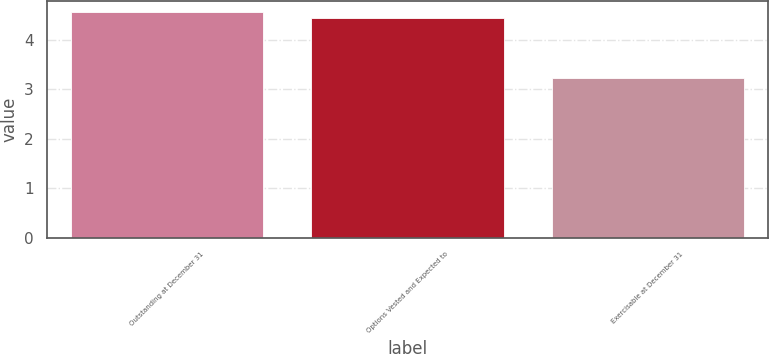Convert chart. <chart><loc_0><loc_0><loc_500><loc_500><bar_chart><fcel>Outstanding at December 31<fcel>Options Vested and Expected to<fcel>Exercisable at December 31<nl><fcel>4.56<fcel>4.44<fcel>3.23<nl></chart> 